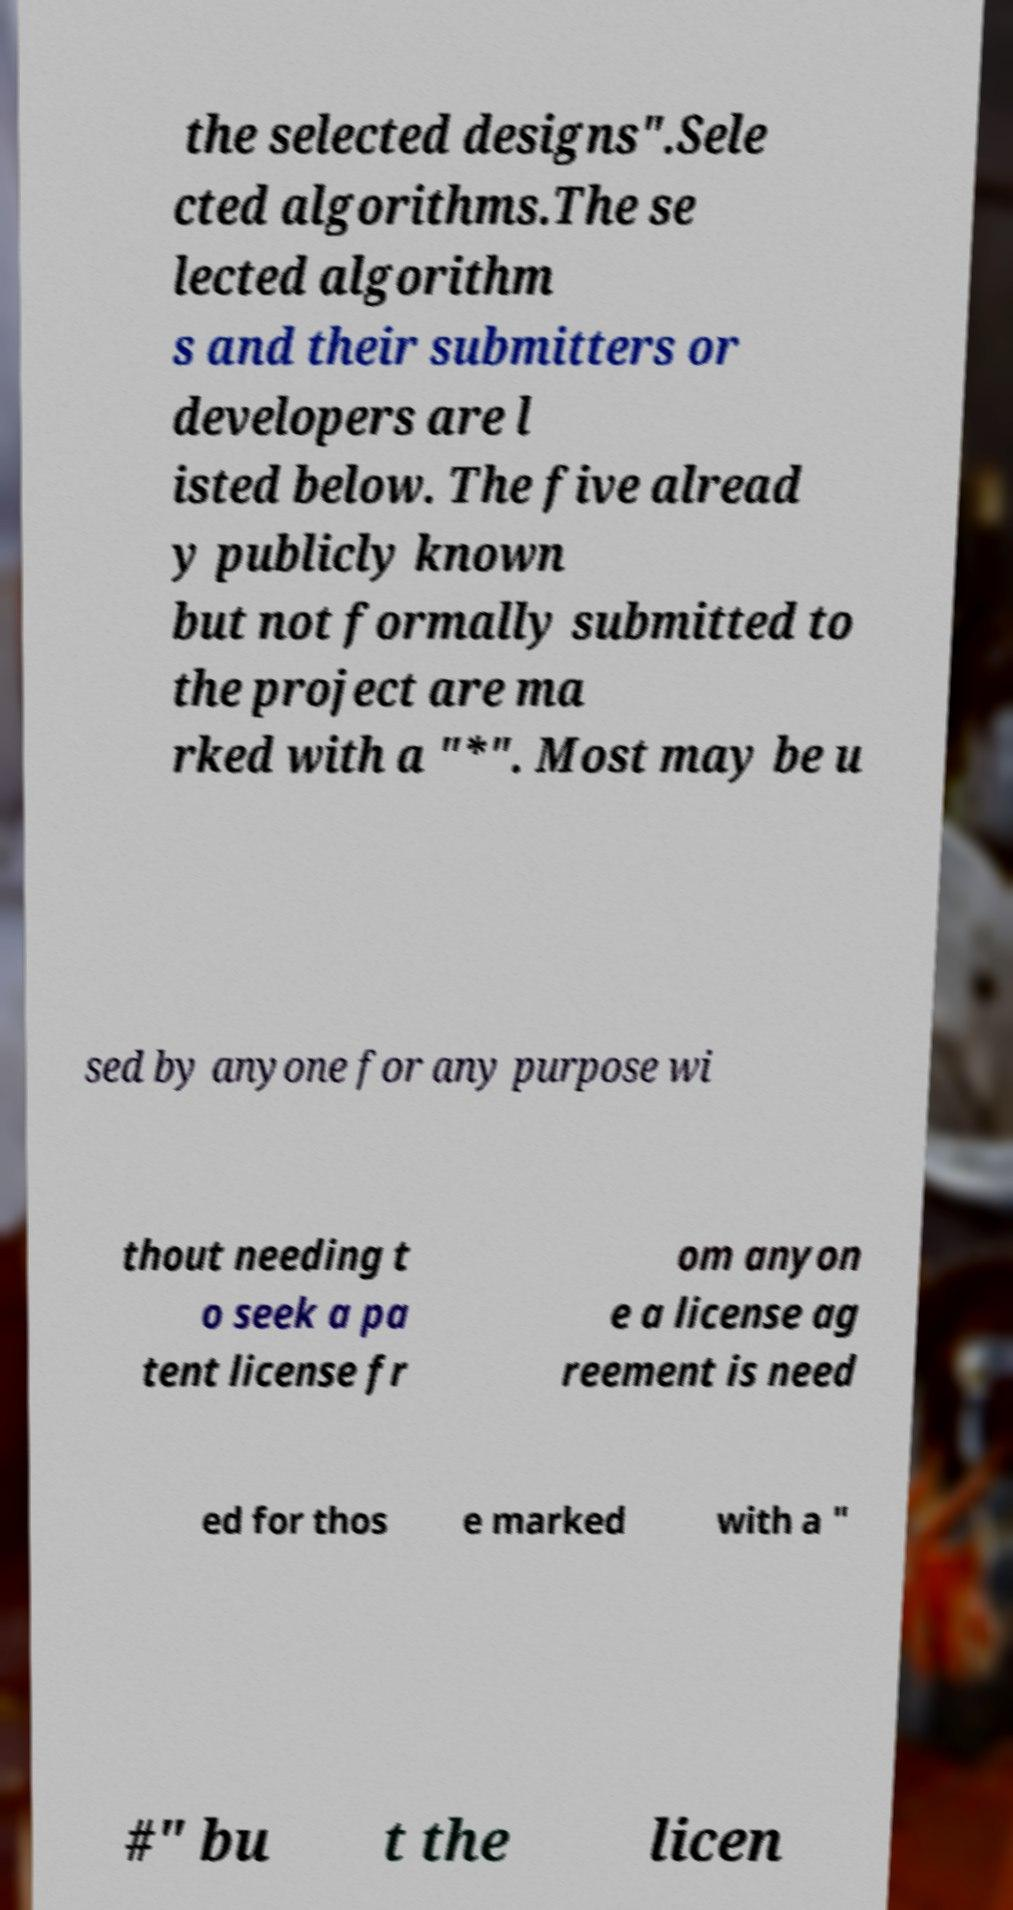Can you read and provide the text displayed in the image?This photo seems to have some interesting text. Can you extract and type it out for me? the selected designs".Sele cted algorithms.The se lected algorithm s and their submitters or developers are l isted below. The five alread y publicly known but not formally submitted to the project are ma rked with a "*". Most may be u sed by anyone for any purpose wi thout needing t o seek a pa tent license fr om anyon e a license ag reement is need ed for thos e marked with a " #" bu t the licen 